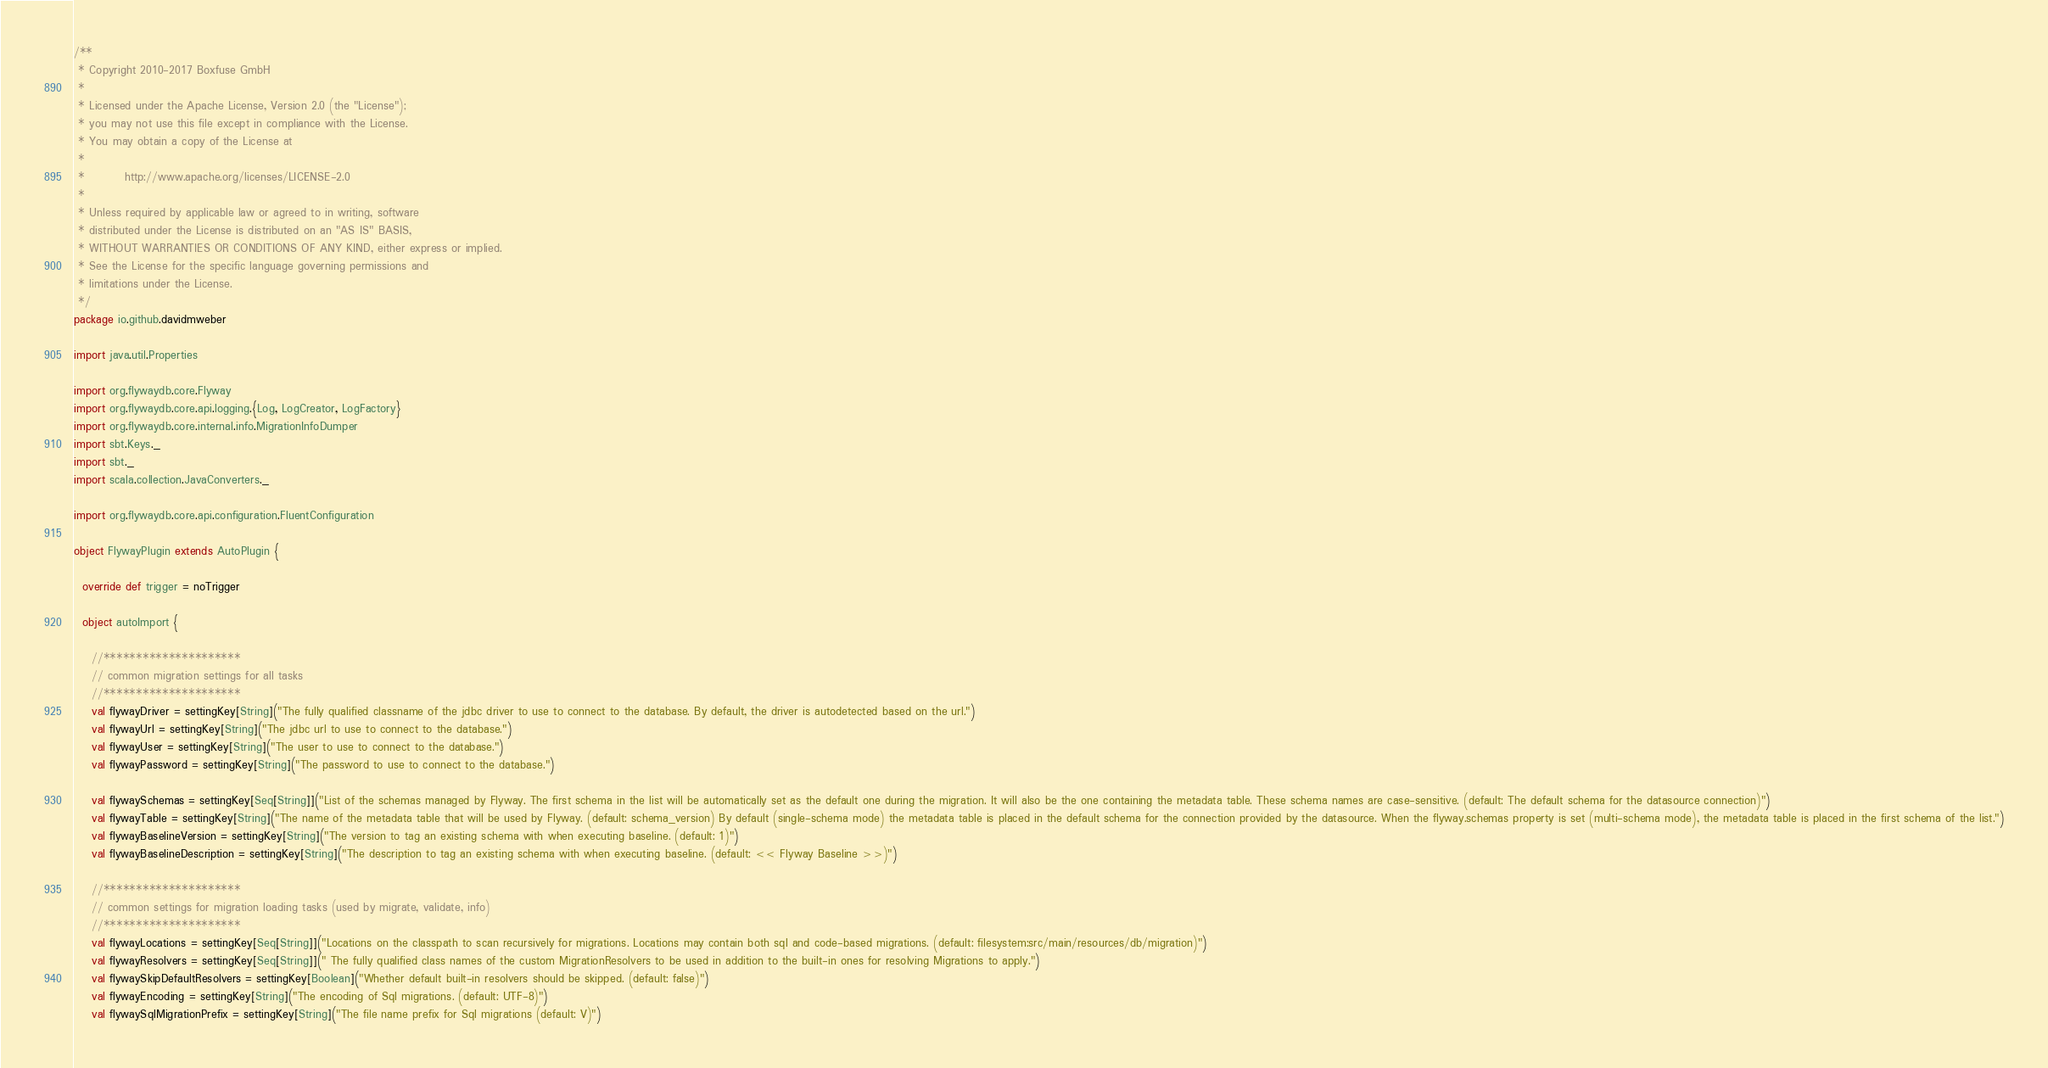Convert code to text. <code><loc_0><loc_0><loc_500><loc_500><_Scala_>/**
 * Copyright 2010-2017 Boxfuse GmbH
 *
 * Licensed under the Apache License, Version 2.0 (the "License");
 * you may not use this file except in compliance with the License.
 * You may obtain a copy of the License at
 *
 *         http://www.apache.org/licenses/LICENSE-2.0
 *
 * Unless required by applicable law or agreed to in writing, software
 * distributed under the License is distributed on an "AS IS" BASIS,
 * WITHOUT WARRANTIES OR CONDITIONS OF ANY KIND, either express or implied.
 * See the License for the specific language governing permissions and
 * limitations under the License.
 */
package io.github.davidmweber

import java.util.Properties

import org.flywaydb.core.Flyway
import org.flywaydb.core.api.logging.{Log, LogCreator, LogFactory}
import org.flywaydb.core.internal.info.MigrationInfoDumper
import sbt.Keys._
import sbt._
import scala.collection.JavaConverters._

import org.flywaydb.core.api.configuration.FluentConfiguration

object FlywayPlugin extends AutoPlugin {

  override def trigger = noTrigger

  object autoImport {

    //*********************
    // common migration settings for all tasks
    //*********************
    val flywayDriver = settingKey[String]("The fully qualified classname of the jdbc driver to use to connect to the database. By default, the driver is autodetected based on the url.")
    val flywayUrl = settingKey[String]("The jdbc url to use to connect to the database.")
    val flywayUser = settingKey[String]("The user to use to connect to the database.")
    val flywayPassword = settingKey[String]("The password to use to connect to the database.")

    val flywaySchemas = settingKey[Seq[String]]("List of the schemas managed by Flyway. The first schema in the list will be automatically set as the default one during the migration. It will also be the one containing the metadata table. These schema names are case-sensitive. (default: The default schema for the datasource connection)")
    val flywayTable = settingKey[String]("The name of the metadata table that will be used by Flyway. (default: schema_version) By default (single-schema mode) the metadata table is placed in the default schema for the connection provided by the datasource. When the flyway.schemas property is set (multi-schema mode), the metadata table is placed in the first schema of the list.")
    val flywayBaselineVersion = settingKey[String]("The version to tag an existing schema with when executing baseline. (default: 1)")
    val flywayBaselineDescription = settingKey[String]("The description to tag an existing schema with when executing baseline. (default: << Flyway Baseline >>)")

    //*********************
    // common settings for migration loading tasks (used by migrate, validate, info)
    //*********************
    val flywayLocations = settingKey[Seq[String]]("Locations on the classpath to scan recursively for migrations. Locations may contain both sql and code-based migrations. (default: filesystem:src/main/resources/db/migration)")
    val flywayResolvers = settingKey[Seq[String]](" The fully qualified class names of the custom MigrationResolvers to be used in addition to the built-in ones for resolving Migrations to apply.")
    val flywaySkipDefaultResolvers = settingKey[Boolean]("Whether default built-in resolvers should be skipped. (default: false)")
    val flywayEncoding = settingKey[String]("The encoding of Sql migrations. (default: UTF-8)")
    val flywaySqlMigrationPrefix = settingKey[String]("The file name prefix for Sql migrations (default: V)")</code> 